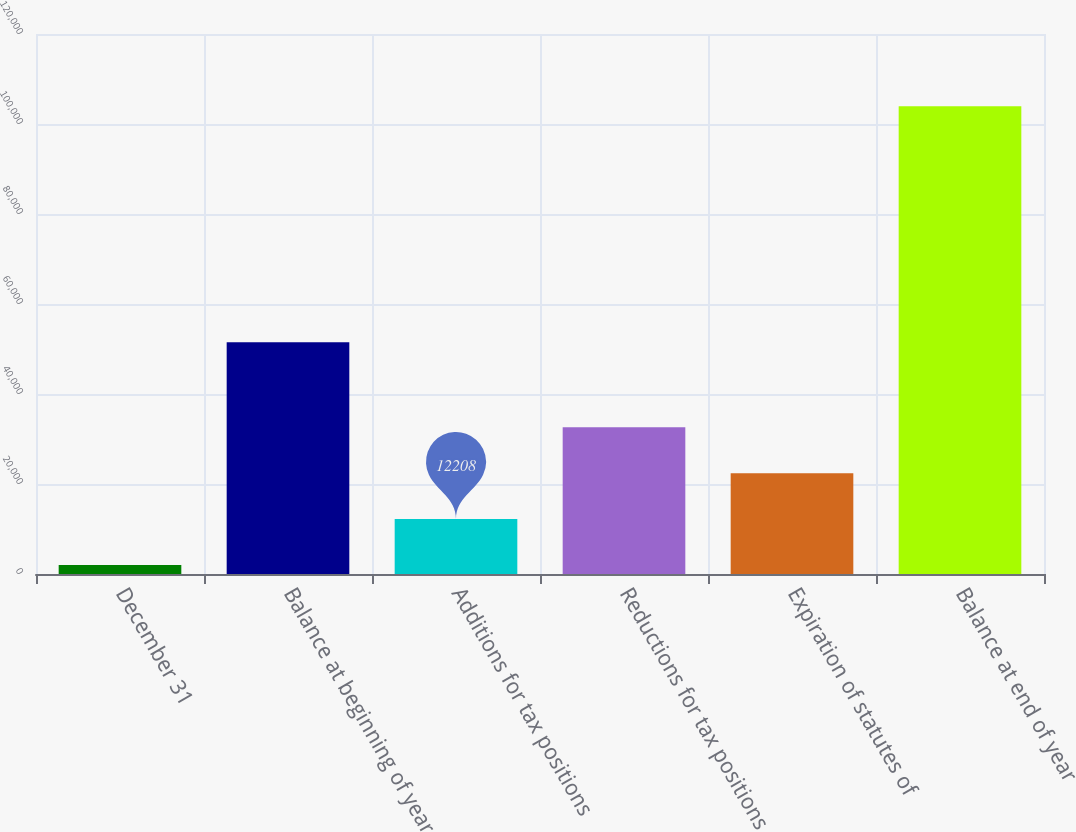<chart> <loc_0><loc_0><loc_500><loc_500><bar_chart><fcel>December 31<fcel>Balance at beginning of year<fcel>Additions for tax positions<fcel>Reductions for tax positions<fcel>Expiration of statutes of<fcel>Balance at end of year<nl><fcel>2013<fcel>51520<fcel>12208<fcel>32598<fcel>22403<fcel>103963<nl></chart> 